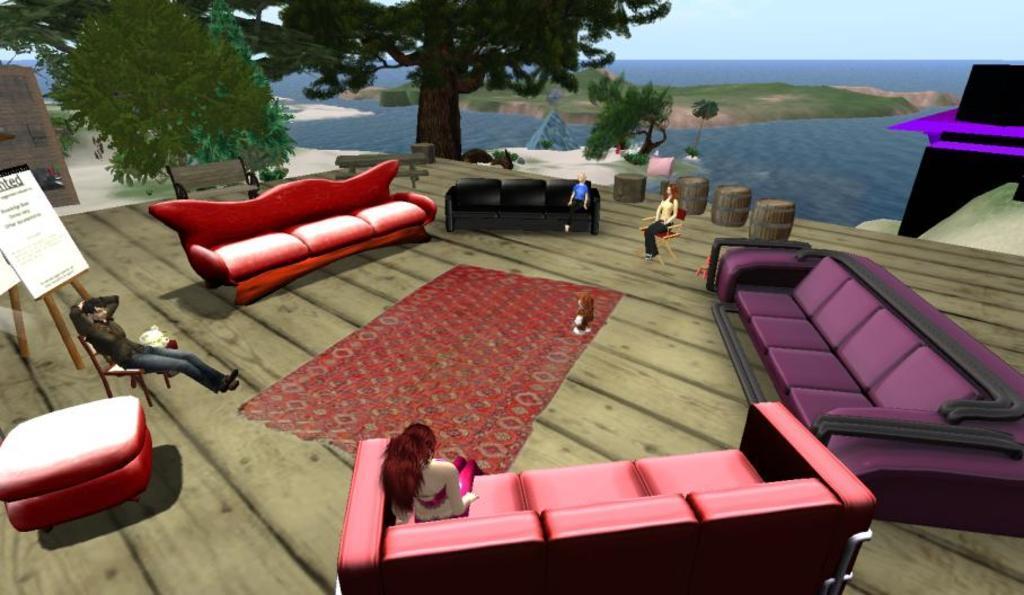Can you describe this image briefly? This is an animation and here we can see sofas and there are some people sitting on them and some are sitting on the chairs and we can see boards, trees, benches, stands and there is water. At the top, there is sky and at the bottom, there is a carpet on the floor. 